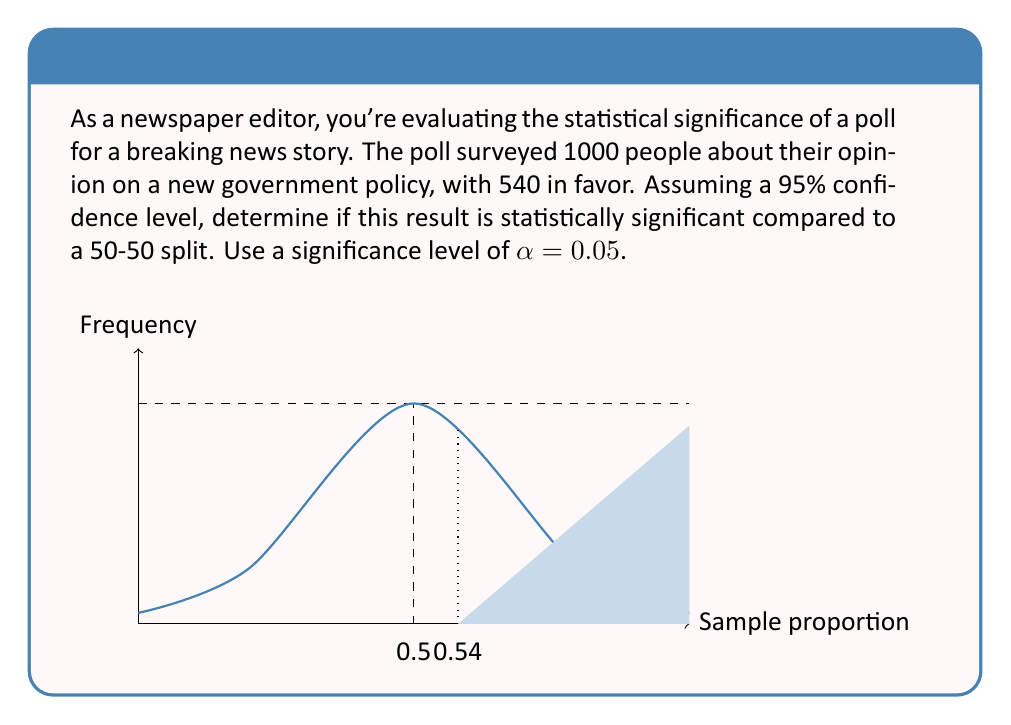Can you solve this math problem? To determine if the poll result is statistically significant, we'll use a z-test for a single proportion. Here's the step-by-step process:

1) First, calculate the sample proportion:
   $p = \frac{540}{1000} = 0.54$

2) The null hypothesis is that the true proportion is 0.5 (50-50 split).
   $H_0: p = 0.5$
   $H_a: p \neq 0.5$ (two-tailed test)

3) Calculate the standard error:
   $SE = \sqrt{\frac{p_0(1-p_0)}{n}} = \sqrt{\frac{0.5(1-0.5)}{1000}} = 0.0158$

4) Calculate the z-score:
   $z = \frac{p - p_0}{SE} = \frac{0.54 - 0.5}{0.0158} = 2.53$

5) For a 95% confidence level (α = 0.05), the critical z-value for a two-tailed test is ±1.96.

6) Since |2.53| > 1.96, we reject the null hypothesis.

7) Calculate the p-value:
   $p-value = 2 * P(Z > 2.53) \approx 0.0114$

8) Since p-value (0.0114) < α (0.05), this confirms that we reject the null hypothesis.

Therefore, the poll result is statistically significant at the 95% confidence level.
Answer: Statistically significant (z = 2.53, p-value = 0.0114 < 0.05) 